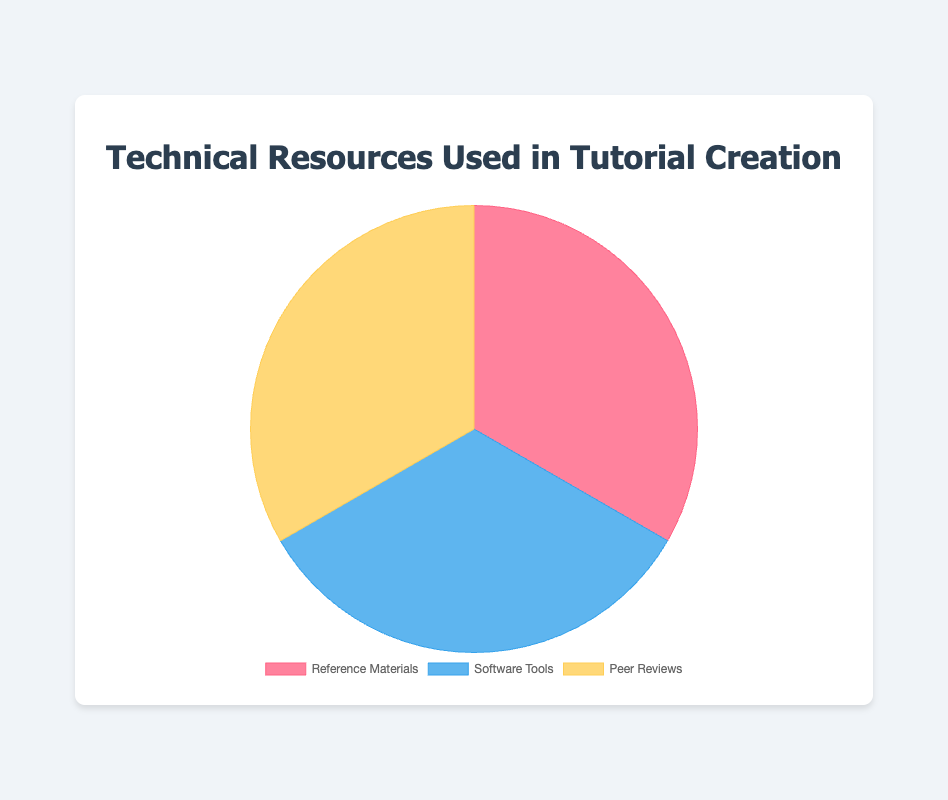Which category has the highest usage percentage in total? By looking at the figure, all categories have equal total percentages (i.e., 100% each), implying that none is higher or lower in total percentage.
Answer: All categories have equal total percentages What does the color red represent in the pie chart? By visually identifying the color red in the pie chart, we see it corresponds to the "Reference Materials" category.
Answer: Reference Materials Compare the usage of "Microsoft Word" and "Grammarly" within the Software Tools category. Which one is used more? From the data, "Microsoft Word" is used 25% and "Grammarly" is used 35% in the Software Tools category. Hence, Grammarly is used more.
Answer: Grammarly What is the total usage percentage of "Books & E-books" and "Official Documentation" in the Reference Materials category? "Books & E-books" has a usage of 30%, and "Official Documentation" has a usage of 40%. Adding these gives a total of 30% + 40% = 70%.
Answer: 70% By examining the chart, which category does the color blue represent? Refer to the visual representation in the chart, blue color corresponds to the "Software Tools" category.
Answer: Software Tools Which category has the lowest usage percentage for its most used resource? The highest usage percentages in each category are: "Official Documentation" (40%), "Adobe Acrobat" (40%), and "Colleague Feedback" (70%). Therefore, "Adobe Acrobat" and "Official Documentation" tie for the lowest highest usage percentage at 40%.
Answer: Software Tools and Reference Materials What is the difference in usage percentages between "Colleague Feedback" and "Professional Editor" in the Peer Reviews category? In the Peer Reviews category, "Colleague Feedback" is 70%, and "Professional Editor" is 10%. The difference is 70% - 10% = 60%.
Answer: 60% What percentage of Software Tools is used other than "Adobe Acrobat"? "Adobe Acrobat" has a usage of 40%. The total for Software Tools is 100%, minus Adobe Acrobat's percentage gives 100% - 40% = 60%.
Answer: 60% Which category is represented by the yellow color in the chart? The yellow color in the chart corresponds to the "Peer Reviews" category upon visual inspection.
Answer: Peer Reviews What is the combined usage percentage of "Stack Overflow" and "Grammarly"? "Stack Overflow" is used 30% and "Grammarly" is used 35%. Adding these percentages gives 30% + 35% = 65%.
Answer: 65% 